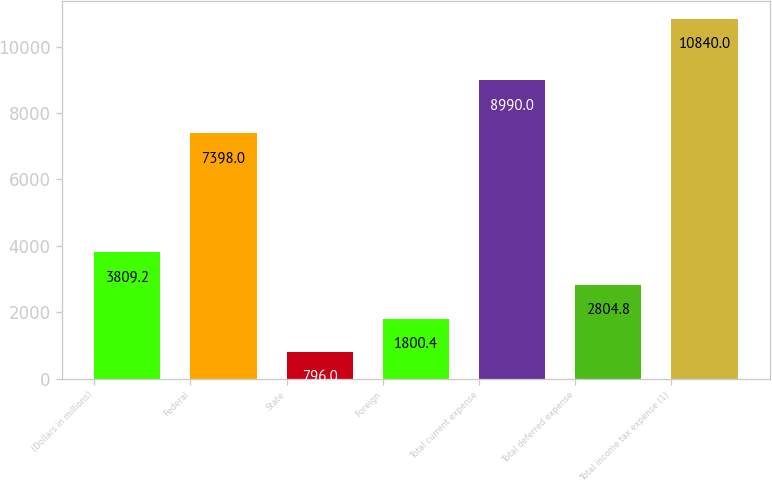Convert chart. <chart><loc_0><loc_0><loc_500><loc_500><bar_chart><fcel>(Dollars in millions)<fcel>Federal<fcel>State<fcel>Foreign<fcel>Total current expense<fcel>Total deferred expense<fcel>Total income tax expense (1)<nl><fcel>3809.2<fcel>7398<fcel>796<fcel>1800.4<fcel>8990<fcel>2804.8<fcel>10840<nl></chart> 